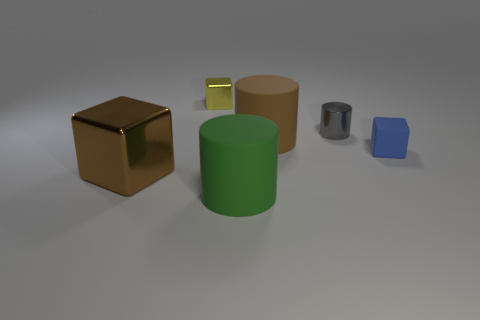Add 2 rubber things. How many objects exist? 8 Add 6 large cylinders. How many large cylinders are left? 8 Add 1 small gray metallic things. How many small gray metallic things exist? 2 Subtract 0 blue cylinders. How many objects are left? 6 Subtract all small rubber cubes. Subtract all big gray balls. How many objects are left? 5 